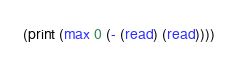Convert code to text. <code><loc_0><loc_0><loc_500><loc_500><_Scheme_>(print (max 0 (- (read) (read))))</code> 